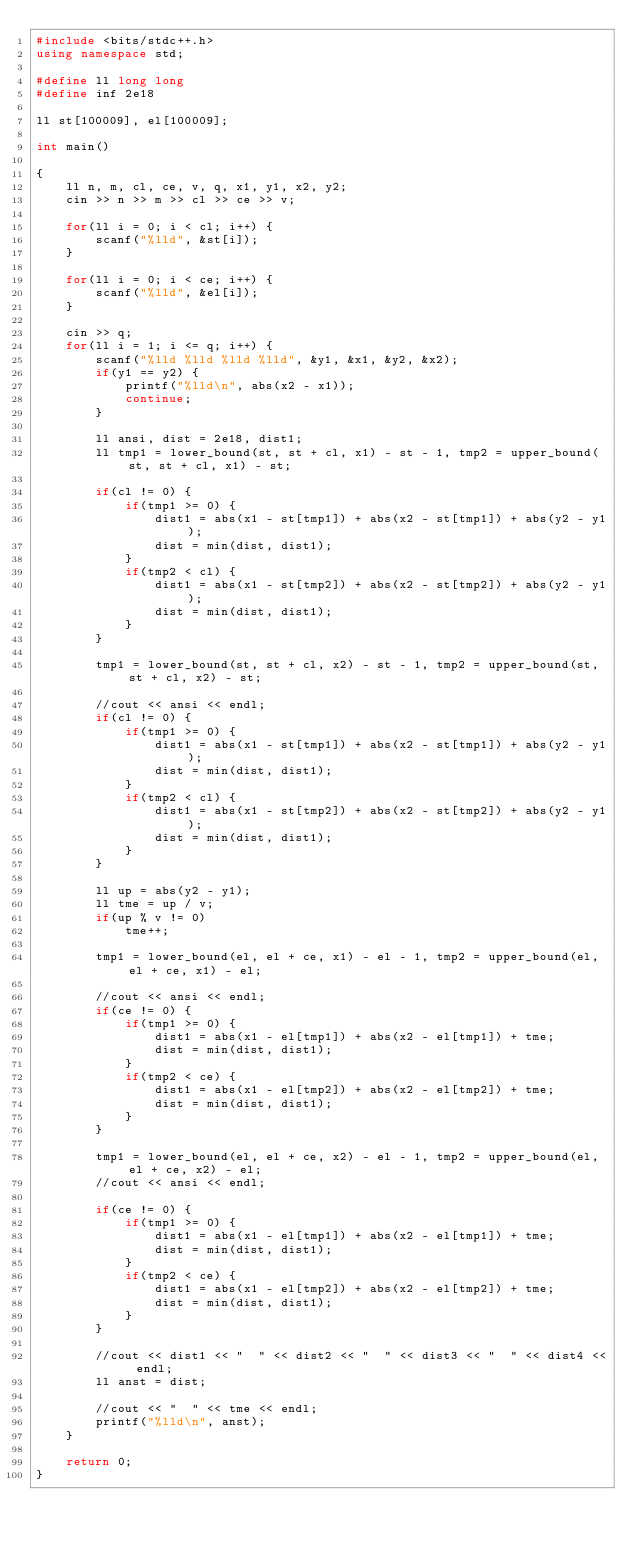<code> <loc_0><loc_0><loc_500><loc_500><_C++_>#include <bits/stdc++.h>
using namespace std;

#define ll long long
#define inf 2e18

ll st[100009], el[100009];

int main()

{
    ll n, m, cl, ce, v, q, x1, y1, x2, y2;
    cin >> n >> m >> cl >> ce >> v;

    for(ll i = 0; i < cl; i++) {
        scanf("%lld", &st[i]);
    }

    for(ll i = 0; i < ce; i++) {
        scanf("%lld", &el[i]);
    }

    cin >> q;
    for(ll i = 1; i <= q; i++) {
        scanf("%lld %lld %lld %lld", &y1, &x1, &y2, &x2);
        if(y1 == y2) {
            printf("%lld\n", abs(x2 - x1));
            continue;
        }

        ll ansi, dist = 2e18, dist1;
        ll tmp1 = lower_bound(st, st + cl, x1) - st - 1, tmp2 = upper_bound(st, st + cl, x1) - st;

        if(cl != 0) {
            if(tmp1 >= 0) {
                dist1 = abs(x1 - st[tmp1]) + abs(x2 - st[tmp1]) + abs(y2 - y1);
                dist = min(dist, dist1);
            }
            if(tmp2 < cl) {
                dist1 = abs(x1 - st[tmp2]) + abs(x2 - st[tmp2]) + abs(y2 - y1);
                dist = min(dist, dist1);
            }
        }

        tmp1 = lower_bound(st, st + cl, x2) - st - 1, tmp2 = upper_bound(st, st + cl, x2) - st;

        //cout << ansi << endl;
        if(cl != 0) {
            if(tmp1 >= 0) {
                dist1 = abs(x1 - st[tmp1]) + abs(x2 - st[tmp1]) + abs(y2 - y1);
                dist = min(dist, dist1);
            }
            if(tmp2 < cl) {
                dist1 = abs(x1 - st[tmp2]) + abs(x2 - st[tmp2]) + abs(y2 - y1);
                dist = min(dist, dist1);
            }
        }

        ll up = abs(y2 - y1);
        ll tme = up / v;
        if(up % v != 0)
            tme++;

        tmp1 = lower_bound(el, el + ce, x1) - el - 1, tmp2 = upper_bound(el, el + ce, x1) - el;

        //cout << ansi << endl;
        if(ce != 0) {
            if(tmp1 >= 0) {
                dist1 = abs(x1 - el[tmp1]) + abs(x2 - el[tmp1]) + tme;
                dist = min(dist, dist1);
            }
            if(tmp2 < ce) {
                dist1 = abs(x1 - el[tmp2]) + abs(x2 - el[tmp2]) + tme;
                dist = min(dist, dist1);
            }
        }

        tmp1 = lower_bound(el, el + ce, x2) - el - 1, tmp2 = upper_bound(el, el + ce, x2) - el;
        //cout << ansi << endl;

        if(ce != 0) {
            if(tmp1 >= 0) {
                dist1 = abs(x1 - el[tmp1]) + abs(x2 - el[tmp1]) + tme;
                dist = min(dist, dist1);
            }
            if(tmp2 < ce) {
                dist1 = abs(x1 - el[tmp2]) + abs(x2 - el[tmp2]) + tme;
                dist = min(dist, dist1);
            }
        }

        //cout << dist1 << "  " << dist2 << "  " << dist3 << "  " << dist4 << endl;
        ll anst = dist;

        //cout << "  " << tme << endl;
        printf("%lld\n", anst);
    }

    return 0;
}</code> 